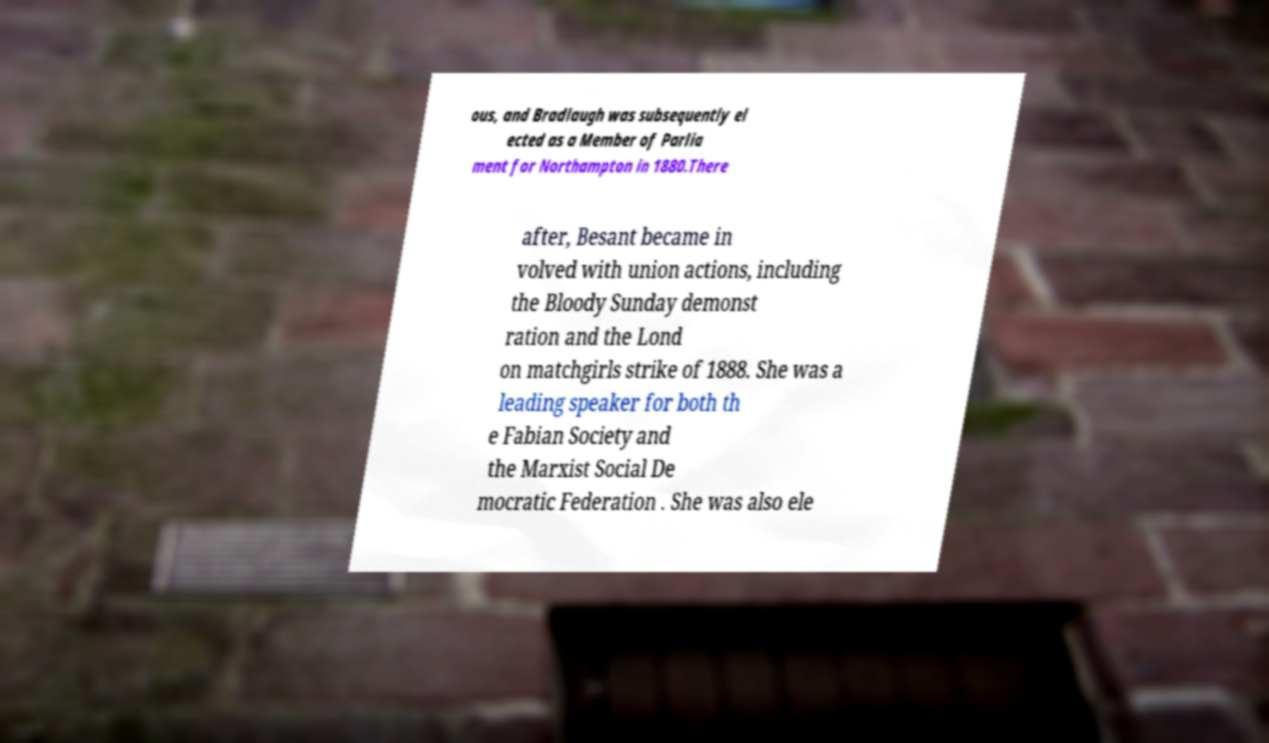Please identify and transcribe the text found in this image. ous, and Bradlaugh was subsequently el ected as a Member of Parlia ment for Northampton in 1880.There after, Besant became in volved with union actions, including the Bloody Sunday demonst ration and the Lond on matchgirls strike of 1888. She was a leading speaker for both th e Fabian Society and the Marxist Social De mocratic Federation . She was also ele 